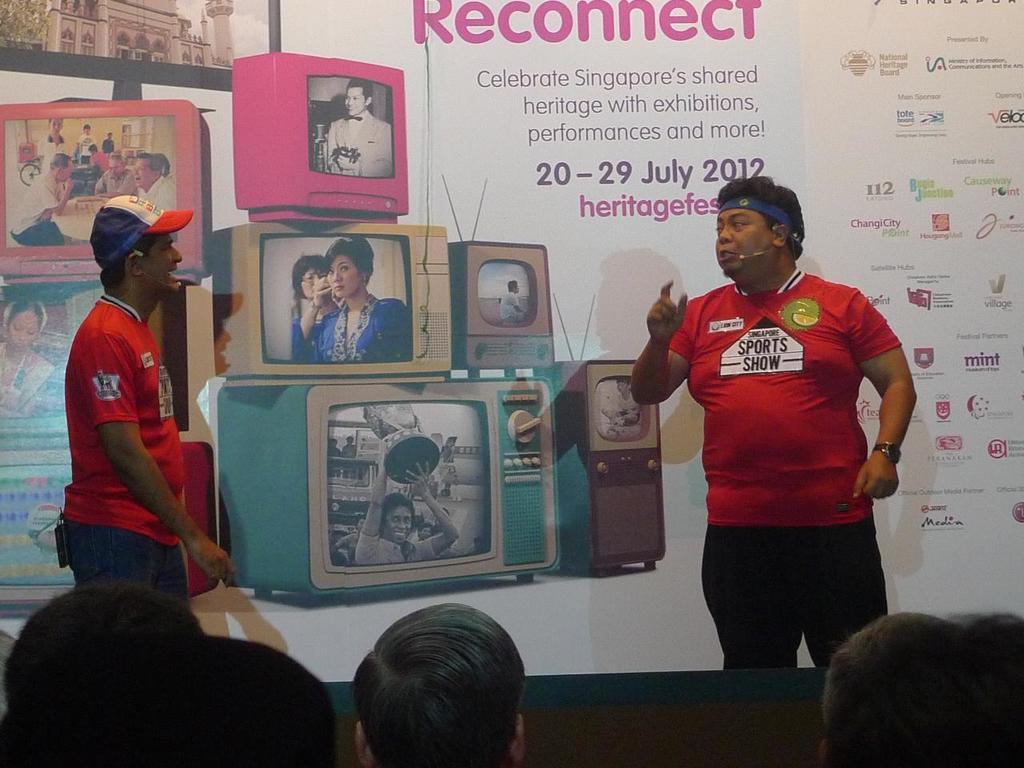Can you describe this image briefly? In this picture there is a man who is wearing t-shirt, mic, watch, and trouser. She is standing on the stage. On the left there is a man who is wearing cap, t-shirt and jeans. He is standing near to the banner. in the banner we can see persons images, television, company logos and quotations. At the bottom we can see the group of persons watching the play. 